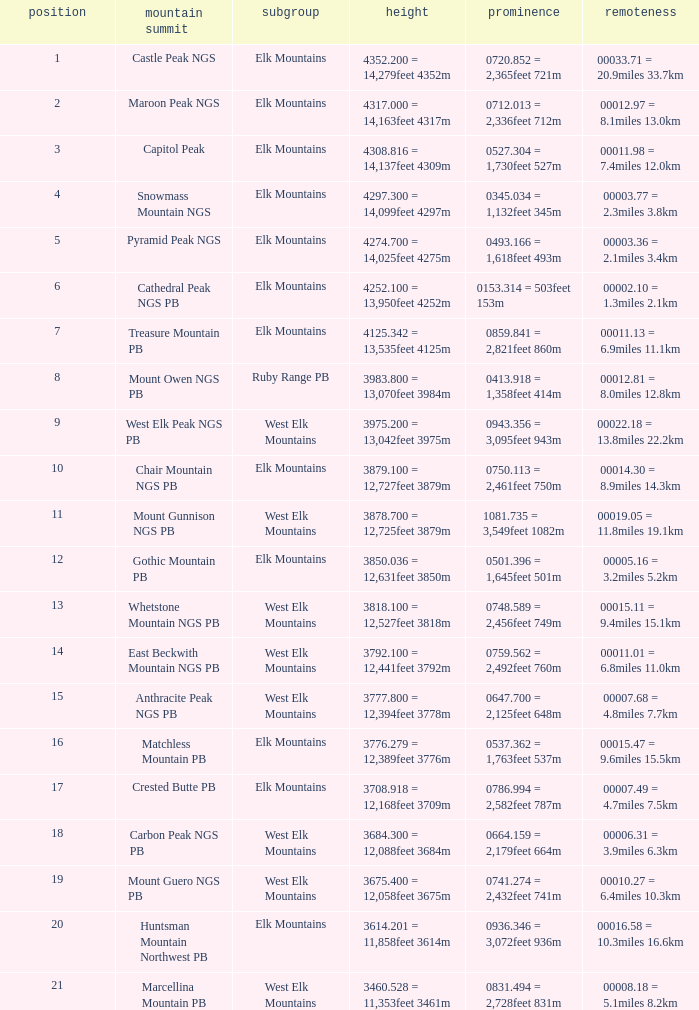Name the Prominence of the Mountain Peak of matchless mountain pb? 0537.362 = 1,763feet 537m. 